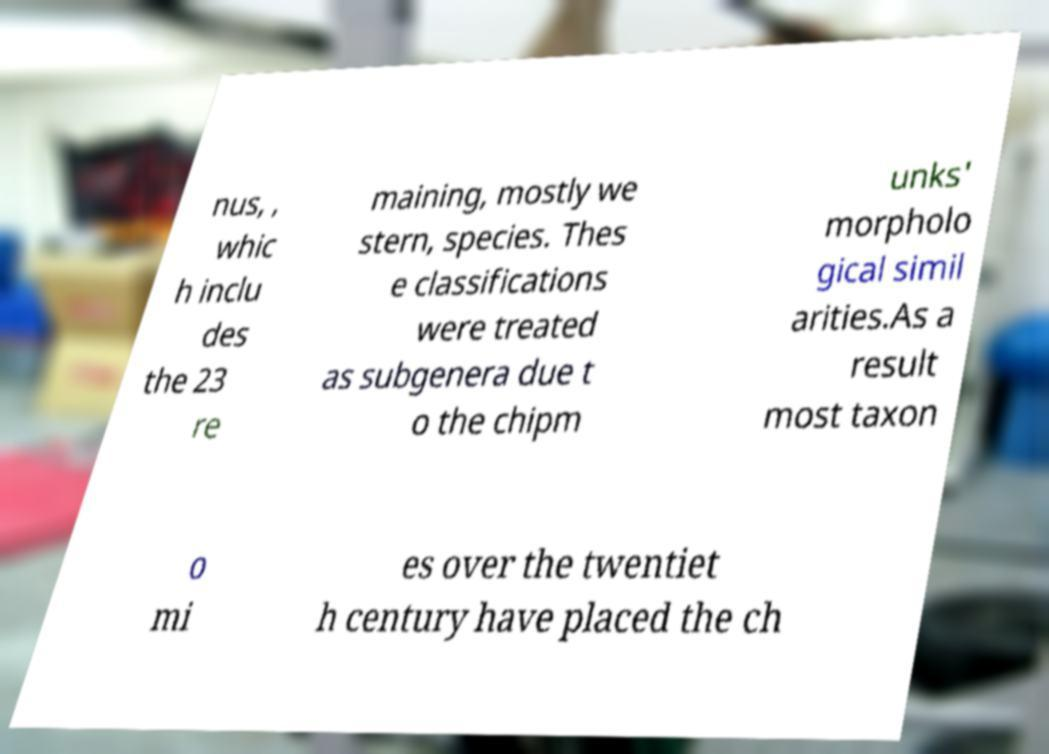Can you read and provide the text displayed in the image?This photo seems to have some interesting text. Can you extract and type it out for me? nus, , whic h inclu des the 23 re maining, mostly we stern, species. Thes e classifications were treated as subgenera due t o the chipm unks' morpholo gical simil arities.As a result most taxon o mi es over the twentiet h century have placed the ch 